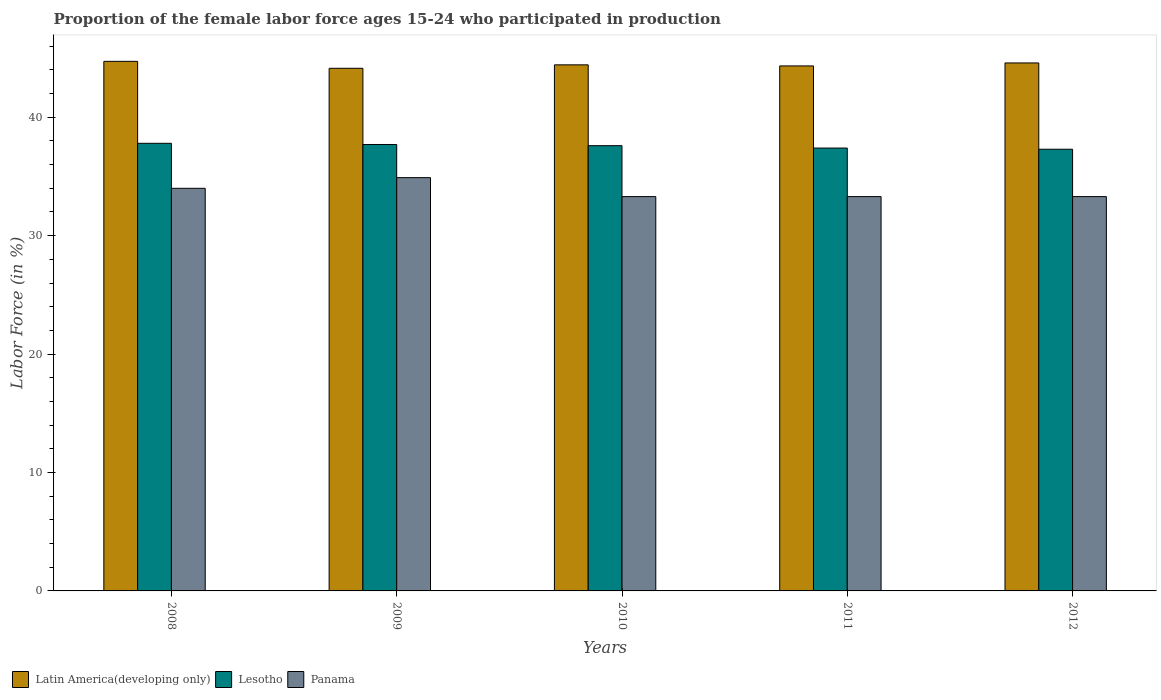How many groups of bars are there?
Give a very brief answer. 5. Are the number of bars on each tick of the X-axis equal?
Keep it short and to the point. Yes. How many bars are there on the 5th tick from the left?
Your answer should be very brief. 3. How many bars are there on the 2nd tick from the right?
Keep it short and to the point. 3. What is the proportion of the female labor force who participated in production in Latin America(developing only) in 2008?
Give a very brief answer. 44.72. Across all years, what is the maximum proportion of the female labor force who participated in production in Panama?
Offer a terse response. 34.9. Across all years, what is the minimum proportion of the female labor force who participated in production in Lesotho?
Keep it short and to the point. 37.3. In which year was the proportion of the female labor force who participated in production in Lesotho minimum?
Offer a terse response. 2012. What is the total proportion of the female labor force who participated in production in Lesotho in the graph?
Offer a very short reply. 187.8. What is the difference between the proportion of the female labor force who participated in production in Latin America(developing only) in 2010 and that in 2011?
Your response must be concise. 0.09. What is the difference between the proportion of the female labor force who participated in production in Lesotho in 2008 and the proportion of the female labor force who participated in production in Panama in 2009?
Your answer should be very brief. 2.9. What is the average proportion of the female labor force who participated in production in Lesotho per year?
Keep it short and to the point. 37.56. In the year 2011, what is the difference between the proportion of the female labor force who participated in production in Lesotho and proportion of the female labor force who participated in production in Panama?
Provide a succinct answer. 4.1. In how many years, is the proportion of the female labor force who participated in production in Panama greater than 8 %?
Provide a succinct answer. 5. What is the ratio of the proportion of the female labor force who participated in production in Latin America(developing only) in 2010 to that in 2011?
Your answer should be compact. 1. Is the proportion of the female labor force who participated in production in Panama in 2011 less than that in 2012?
Offer a terse response. No. Is the difference between the proportion of the female labor force who participated in production in Lesotho in 2010 and 2012 greater than the difference between the proportion of the female labor force who participated in production in Panama in 2010 and 2012?
Ensure brevity in your answer.  Yes. What is the difference between the highest and the second highest proportion of the female labor force who participated in production in Lesotho?
Make the answer very short. 0.1. What is the difference between the highest and the lowest proportion of the female labor force who participated in production in Panama?
Ensure brevity in your answer.  1.6. Is the sum of the proportion of the female labor force who participated in production in Panama in 2010 and 2011 greater than the maximum proportion of the female labor force who participated in production in Lesotho across all years?
Provide a succinct answer. Yes. What does the 3rd bar from the left in 2009 represents?
Ensure brevity in your answer.  Panama. What does the 1st bar from the right in 2012 represents?
Your answer should be very brief. Panama. How many bars are there?
Your answer should be compact. 15. What is the difference between two consecutive major ticks on the Y-axis?
Provide a succinct answer. 10. Are the values on the major ticks of Y-axis written in scientific E-notation?
Your response must be concise. No. Does the graph contain any zero values?
Your answer should be very brief. No. Does the graph contain grids?
Give a very brief answer. No. How are the legend labels stacked?
Ensure brevity in your answer.  Horizontal. What is the title of the graph?
Your answer should be very brief. Proportion of the female labor force ages 15-24 who participated in production. What is the Labor Force (in %) in Latin America(developing only) in 2008?
Keep it short and to the point. 44.72. What is the Labor Force (in %) in Lesotho in 2008?
Ensure brevity in your answer.  37.8. What is the Labor Force (in %) in Latin America(developing only) in 2009?
Your answer should be compact. 44.14. What is the Labor Force (in %) of Lesotho in 2009?
Offer a very short reply. 37.7. What is the Labor Force (in %) of Panama in 2009?
Give a very brief answer. 34.9. What is the Labor Force (in %) in Latin America(developing only) in 2010?
Keep it short and to the point. 44.43. What is the Labor Force (in %) in Lesotho in 2010?
Give a very brief answer. 37.6. What is the Labor Force (in %) in Panama in 2010?
Provide a short and direct response. 33.3. What is the Labor Force (in %) in Latin America(developing only) in 2011?
Offer a very short reply. 44.33. What is the Labor Force (in %) of Lesotho in 2011?
Your answer should be very brief. 37.4. What is the Labor Force (in %) in Panama in 2011?
Offer a very short reply. 33.3. What is the Labor Force (in %) of Latin America(developing only) in 2012?
Provide a succinct answer. 44.59. What is the Labor Force (in %) in Lesotho in 2012?
Provide a short and direct response. 37.3. What is the Labor Force (in %) in Panama in 2012?
Ensure brevity in your answer.  33.3. Across all years, what is the maximum Labor Force (in %) in Latin America(developing only)?
Provide a succinct answer. 44.72. Across all years, what is the maximum Labor Force (in %) in Lesotho?
Your response must be concise. 37.8. Across all years, what is the maximum Labor Force (in %) of Panama?
Your answer should be very brief. 34.9. Across all years, what is the minimum Labor Force (in %) in Latin America(developing only)?
Offer a terse response. 44.14. Across all years, what is the minimum Labor Force (in %) in Lesotho?
Offer a very short reply. 37.3. Across all years, what is the minimum Labor Force (in %) in Panama?
Offer a very short reply. 33.3. What is the total Labor Force (in %) in Latin America(developing only) in the graph?
Your answer should be compact. 222.21. What is the total Labor Force (in %) in Lesotho in the graph?
Offer a terse response. 187.8. What is the total Labor Force (in %) in Panama in the graph?
Provide a succinct answer. 168.8. What is the difference between the Labor Force (in %) of Latin America(developing only) in 2008 and that in 2009?
Your answer should be very brief. 0.59. What is the difference between the Labor Force (in %) of Panama in 2008 and that in 2009?
Keep it short and to the point. -0.9. What is the difference between the Labor Force (in %) in Latin America(developing only) in 2008 and that in 2010?
Provide a short and direct response. 0.29. What is the difference between the Labor Force (in %) of Lesotho in 2008 and that in 2010?
Provide a short and direct response. 0.2. What is the difference between the Labor Force (in %) in Latin America(developing only) in 2008 and that in 2011?
Offer a terse response. 0.39. What is the difference between the Labor Force (in %) in Panama in 2008 and that in 2011?
Offer a very short reply. 0.7. What is the difference between the Labor Force (in %) of Latin America(developing only) in 2008 and that in 2012?
Make the answer very short. 0.13. What is the difference between the Labor Force (in %) of Latin America(developing only) in 2009 and that in 2010?
Give a very brief answer. -0.29. What is the difference between the Labor Force (in %) in Lesotho in 2009 and that in 2010?
Make the answer very short. 0.1. What is the difference between the Labor Force (in %) in Latin America(developing only) in 2009 and that in 2011?
Ensure brevity in your answer.  -0.2. What is the difference between the Labor Force (in %) of Panama in 2009 and that in 2011?
Provide a short and direct response. 1.6. What is the difference between the Labor Force (in %) in Latin America(developing only) in 2009 and that in 2012?
Provide a short and direct response. -0.45. What is the difference between the Labor Force (in %) of Lesotho in 2009 and that in 2012?
Your answer should be compact. 0.4. What is the difference between the Labor Force (in %) in Panama in 2009 and that in 2012?
Your answer should be compact. 1.6. What is the difference between the Labor Force (in %) in Latin America(developing only) in 2010 and that in 2011?
Offer a terse response. 0.09. What is the difference between the Labor Force (in %) of Lesotho in 2010 and that in 2011?
Offer a terse response. 0.2. What is the difference between the Labor Force (in %) of Latin America(developing only) in 2010 and that in 2012?
Provide a short and direct response. -0.16. What is the difference between the Labor Force (in %) of Lesotho in 2010 and that in 2012?
Ensure brevity in your answer.  0.3. What is the difference between the Labor Force (in %) in Panama in 2010 and that in 2012?
Offer a terse response. 0. What is the difference between the Labor Force (in %) of Latin America(developing only) in 2011 and that in 2012?
Your answer should be compact. -0.25. What is the difference between the Labor Force (in %) in Lesotho in 2011 and that in 2012?
Your answer should be very brief. 0.1. What is the difference between the Labor Force (in %) in Panama in 2011 and that in 2012?
Keep it short and to the point. 0. What is the difference between the Labor Force (in %) of Latin America(developing only) in 2008 and the Labor Force (in %) of Lesotho in 2009?
Your answer should be compact. 7.02. What is the difference between the Labor Force (in %) in Latin America(developing only) in 2008 and the Labor Force (in %) in Panama in 2009?
Ensure brevity in your answer.  9.82. What is the difference between the Labor Force (in %) of Latin America(developing only) in 2008 and the Labor Force (in %) of Lesotho in 2010?
Make the answer very short. 7.12. What is the difference between the Labor Force (in %) in Latin America(developing only) in 2008 and the Labor Force (in %) in Panama in 2010?
Offer a very short reply. 11.42. What is the difference between the Labor Force (in %) in Latin America(developing only) in 2008 and the Labor Force (in %) in Lesotho in 2011?
Your response must be concise. 7.32. What is the difference between the Labor Force (in %) in Latin America(developing only) in 2008 and the Labor Force (in %) in Panama in 2011?
Provide a succinct answer. 11.42. What is the difference between the Labor Force (in %) in Lesotho in 2008 and the Labor Force (in %) in Panama in 2011?
Provide a short and direct response. 4.5. What is the difference between the Labor Force (in %) in Latin America(developing only) in 2008 and the Labor Force (in %) in Lesotho in 2012?
Give a very brief answer. 7.42. What is the difference between the Labor Force (in %) in Latin America(developing only) in 2008 and the Labor Force (in %) in Panama in 2012?
Provide a short and direct response. 11.42. What is the difference between the Labor Force (in %) of Lesotho in 2008 and the Labor Force (in %) of Panama in 2012?
Your response must be concise. 4.5. What is the difference between the Labor Force (in %) of Latin America(developing only) in 2009 and the Labor Force (in %) of Lesotho in 2010?
Your response must be concise. 6.54. What is the difference between the Labor Force (in %) of Latin America(developing only) in 2009 and the Labor Force (in %) of Panama in 2010?
Provide a succinct answer. 10.84. What is the difference between the Labor Force (in %) of Latin America(developing only) in 2009 and the Labor Force (in %) of Lesotho in 2011?
Ensure brevity in your answer.  6.74. What is the difference between the Labor Force (in %) of Latin America(developing only) in 2009 and the Labor Force (in %) of Panama in 2011?
Keep it short and to the point. 10.84. What is the difference between the Labor Force (in %) in Lesotho in 2009 and the Labor Force (in %) in Panama in 2011?
Provide a short and direct response. 4.4. What is the difference between the Labor Force (in %) in Latin America(developing only) in 2009 and the Labor Force (in %) in Lesotho in 2012?
Offer a very short reply. 6.84. What is the difference between the Labor Force (in %) in Latin America(developing only) in 2009 and the Labor Force (in %) in Panama in 2012?
Offer a terse response. 10.84. What is the difference between the Labor Force (in %) in Latin America(developing only) in 2010 and the Labor Force (in %) in Lesotho in 2011?
Provide a short and direct response. 7.03. What is the difference between the Labor Force (in %) of Latin America(developing only) in 2010 and the Labor Force (in %) of Panama in 2011?
Provide a succinct answer. 11.13. What is the difference between the Labor Force (in %) in Latin America(developing only) in 2010 and the Labor Force (in %) in Lesotho in 2012?
Your answer should be compact. 7.13. What is the difference between the Labor Force (in %) in Latin America(developing only) in 2010 and the Labor Force (in %) in Panama in 2012?
Your response must be concise. 11.13. What is the difference between the Labor Force (in %) of Latin America(developing only) in 2011 and the Labor Force (in %) of Lesotho in 2012?
Ensure brevity in your answer.  7.04. What is the difference between the Labor Force (in %) of Latin America(developing only) in 2011 and the Labor Force (in %) of Panama in 2012?
Offer a terse response. 11.04. What is the average Labor Force (in %) in Latin America(developing only) per year?
Provide a succinct answer. 44.44. What is the average Labor Force (in %) in Lesotho per year?
Provide a short and direct response. 37.56. What is the average Labor Force (in %) in Panama per year?
Provide a short and direct response. 33.76. In the year 2008, what is the difference between the Labor Force (in %) of Latin America(developing only) and Labor Force (in %) of Lesotho?
Offer a terse response. 6.92. In the year 2008, what is the difference between the Labor Force (in %) in Latin America(developing only) and Labor Force (in %) in Panama?
Give a very brief answer. 10.72. In the year 2008, what is the difference between the Labor Force (in %) of Lesotho and Labor Force (in %) of Panama?
Keep it short and to the point. 3.8. In the year 2009, what is the difference between the Labor Force (in %) in Latin America(developing only) and Labor Force (in %) in Lesotho?
Your response must be concise. 6.44. In the year 2009, what is the difference between the Labor Force (in %) of Latin America(developing only) and Labor Force (in %) of Panama?
Your answer should be compact. 9.24. In the year 2010, what is the difference between the Labor Force (in %) in Latin America(developing only) and Labor Force (in %) in Lesotho?
Ensure brevity in your answer.  6.83. In the year 2010, what is the difference between the Labor Force (in %) of Latin America(developing only) and Labor Force (in %) of Panama?
Offer a terse response. 11.13. In the year 2011, what is the difference between the Labor Force (in %) of Latin America(developing only) and Labor Force (in %) of Lesotho?
Your answer should be very brief. 6.93. In the year 2011, what is the difference between the Labor Force (in %) in Latin America(developing only) and Labor Force (in %) in Panama?
Offer a terse response. 11.04. In the year 2011, what is the difference between the Labor Force (in %) in Lesotho and Labor Force (in %) in Panama?
Offer a terse response. 4.1. In the year 2012, what is the difference between the Labor Force (in %) in Latin America(developing only) and Labor Force (in %) in Lesotho?
Ensure brevity in your answer.  7.29. In the year 2012, what is the difference between the Labor Force (in %) of Latin America(developing only) and Labor Force (in %) of Panama?
Ensure brevity in your answer.  11.29. In the year 2012, what is the difference between the Labor Force (in %) in Lesotho and Labor Force (in %) in Panama?
Provide a short and direct response. 4. What is the ratio of the Labor Force (in %) in Latin America(developing only) in 2008 to that in 2009?
Ensure brevity in your answer.  1.01. What is the ratio of the Labor Force (in %) of Lesotho in 2008 to that in 2009?
Make the answer very short. 1. What is the ratio of the Labor Force (in %) in Panama in 2008 to that in 2009?
Provide a succinct answer. 0.97. What is the ratio of the Labor Force (in %) in Latin America(developing only) in 2008 to that in 2010?
Your answer should be compact. 1.01. What is the ratio of the Labor Force (in %) in Panama in 2008 to that in 2010?
Your answer should be compact. 1.02. What is the ratio of the Labor Force (in %) in Latin America(developing only) in 2008 to that in 2011?
Ensure brevity in your answer.  1.01. What is the ratio of the Labor Force (in %) of Lesotho in 2008 to that in 2011?
Offer a terse response. 1.01. What is the ratio of the Labor Force (in %) of Panama in 2008 to that in 2011?
Your answer should be very brief. 1.02. What is the ratio of the Labor Force (in %) of Lesotho in 2008 to that in 2012?
Your answer should be very brief. 1.01. What is the ratio of the Labor Force (in %) in Panama in 2008 to that in 2012?
Ensure brevity in your answer.  1.02. What is the ratio of the Labor Force (in %) in Latin America(developing only) in 2009 to that in 2010?
Offer a very short reply. 0.99. What is the ratio of the Labor Force (in %) of Lesotho in 2009 to that in 2010?
Your answer should be compact. 1. What is the ratio of the Labor Force (in %) in Panama in 2009 to that in 2010?
Offer a terse response. 1.05. What is the ratio of the Labor Force (in %) of Latin America(developing only) in 2009 to that in 2011?
Your response must be concise. 1. What is the ratio of the Labor Force (in %) in Lesotho in 2009 to that in 2011?
Ensure brevity in your answer.  1.01. What is the ratio of the Labor Force (in %) of Panama in 2009 to that in 2011?
Your response must be concise. 1.05. What is the ratio of the Labor Force (in %) in Latin America(developing only) in 2009 to that in 2012?
Keep it short and to the point. 0.99. What is the ratio of the Labor Force (in %) in Lesotho in 2009 to that in 2012?
Ensure brevity in your answer.  1.01. What is the ratio of the Labor Force (in %) in Panama in 2009 to that in 2012?
Your response must be concise. 1.05. What is the ratio of the Labor Force (in %) in Lesotho in 2010 to that in 2011?
Offer a terse response. 1.01. What is the ratio of the Labor Force (in %) in Panama in 2010 to that in 2011?
Offer a very short reply. 1. What is the ratio of the Labor Force (in %) in Lesotho in 2010 to that in 2012?
Your answer should be compact. 1.01. What is the ratio of the Labor Force (in %) of Latin America(developing only) in 2011 to that in 2012?
Make the answer very short. 0.99. What is the difference between the highest and the second highest Labor Force (in %) of Latin America(developing only)?
Offer a terse response. 0.13. What is the difference between the highest and the second highest Labor Force (in %) of Panama?
Offer a very short reply. 0.9. What is the difference between the highest and the lowest Labor Force (in %) in Latin America(developing only)?
Provide a succinct answer. 0.59. 